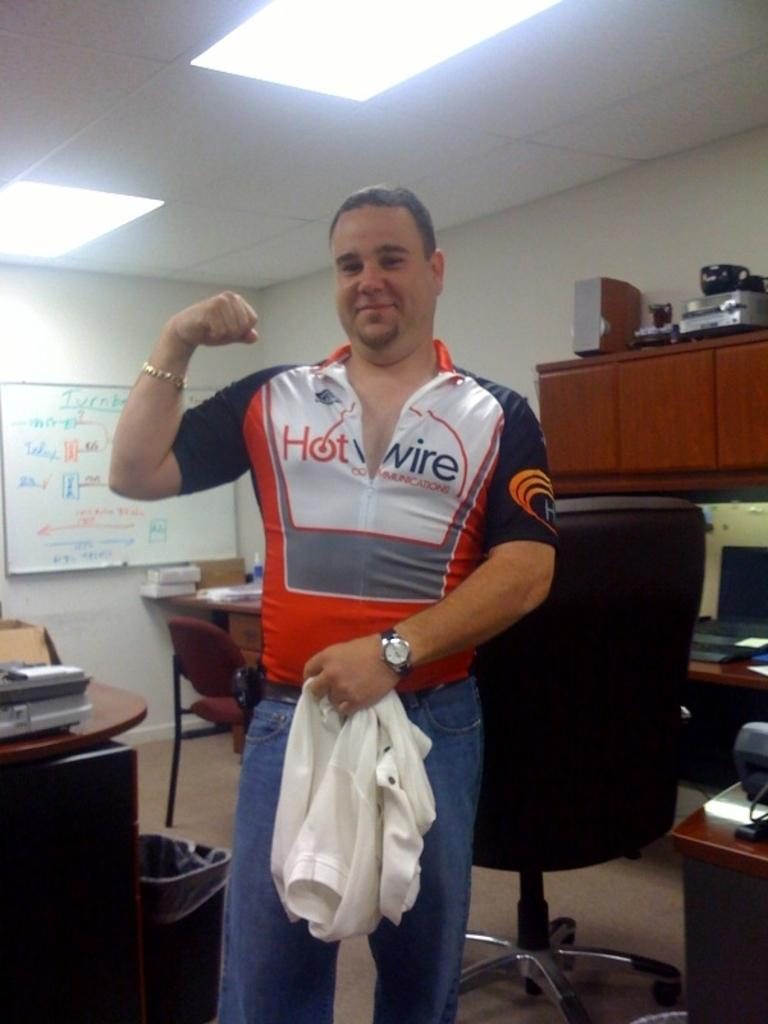<image>
Present a compact description of the photo's key features. A man is wearing a shirt with the words hot wire on it. 